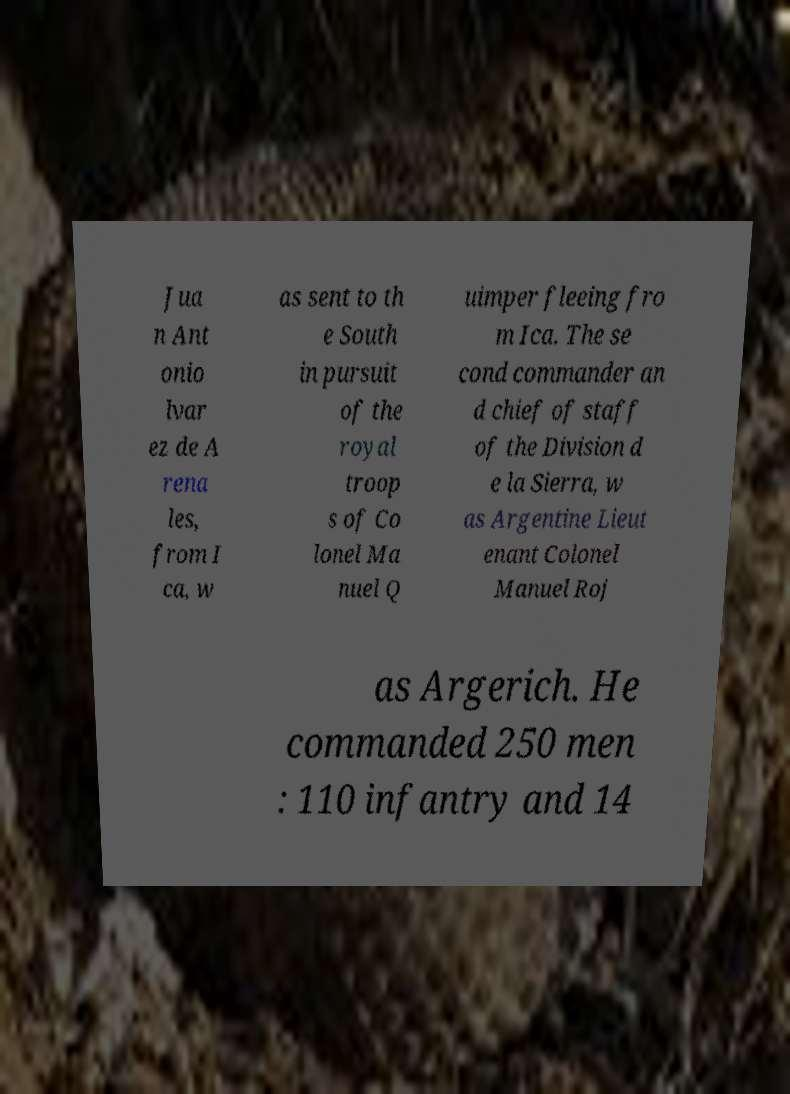There's text embedded in this image that I need extracted. Can you transcribe it verbatim? Jua n Ant onio lvar ez de A rena les, from I ca, w as sent to th e South in pursuit of the royal troop s of Co lonel Ma nuel Q uimper fleeing fro m Ica. The se cond commander an d chief of staff of the Division d e la Sierra, w as Argentine Lieut enant Colonel Manuel Roj as Argerich. He commanded 250 men : 110 infantry and 14 